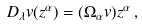Convert formula to latex. <formula><loc_0><loc_0><loc_500><loc_500>D _ { \lambda } { v } ( z ^ { \alpha } ) = ( \Omega _ { \alpha } { v } ) z ^ { \alpha } \, ,</formula> 